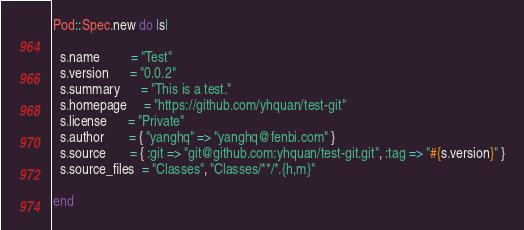Convert code to text. <code><loc_0><loc_0><loc_500><loc_500><_Ruby_>Pod::Spec.new do |s|

  s.name         = "Test"
  s.version      = "0.0.2"
  s.summary      = "This is a test."
  s.homepage     = "https://github.com/yhquan/test-git"
  s.license      = "Private"
  s.author       = { "yanghq" => "yanghq@fenbi.com" }
  s.source       = { :git => "git@github.com:yhquan/test-git.git", :tag => "#{s.version}" }
  s.source_files  = "Classes", "Classes/**/*.{h,m}"

end
</code> 